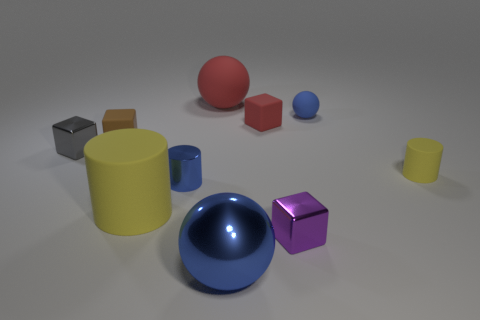Is there anything else of the same color as the small sphere?
Keep it short and to the point. Yes. What is the yellow cylinder to the left of the large thing in front of the small purple shiny thing made of?
Your response must be concise. Rubber. Does the large blue sphere have the same material as the gray block that is left of the red cube?
Give a very brief answer. Yes. How many objects are yellow things that are to the right of the small shiny cylinder or large gray metallic things?
Ensure brevity in your answer.  1. Are there any matte objects that have the same color as the big rubber sphere?
Keep it short and to the point. Yes. There is a purple thing; does it have the same shape as the red object in front of the tiny blue ball?
Give a very brief answer. Yes. What number of things are both behind the tiny purple shiny cube and in front of the small blue metallic thing?
Provide a succinct answer. 1. What material is the other blue object that is the same shape as the large blue object?
Your response must be concise. Rubber. There is a blue ball that is in front of the small metallic cube that is to the left of the red rubber sphere; how big is it?
Provide a short and direct response. Large. Are any big yellow cylinders visible?
Provide a succinct answer. Yes. 